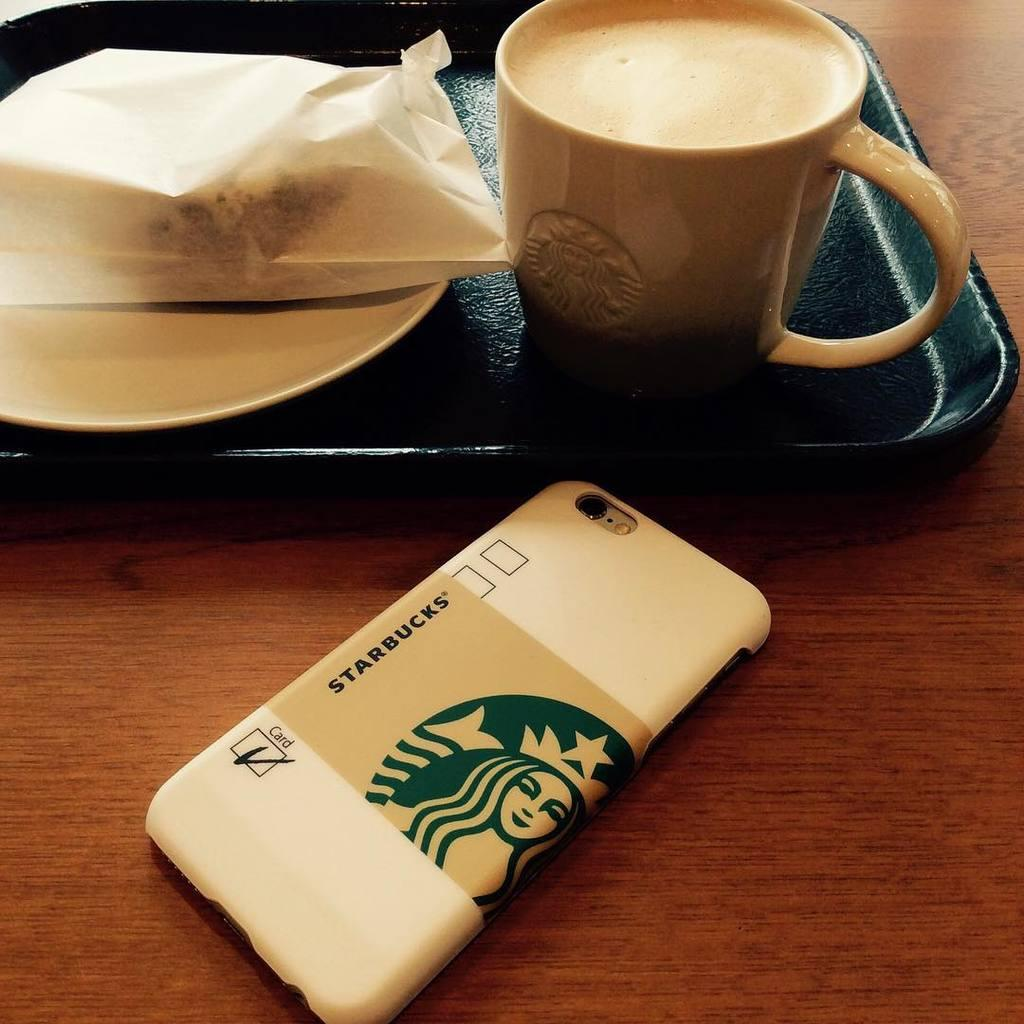Provide a one-sentence caption for the provided image. the Starbucks coffee in a black tray  placed near to Starbucks symbol and letters printed back of the phone. 